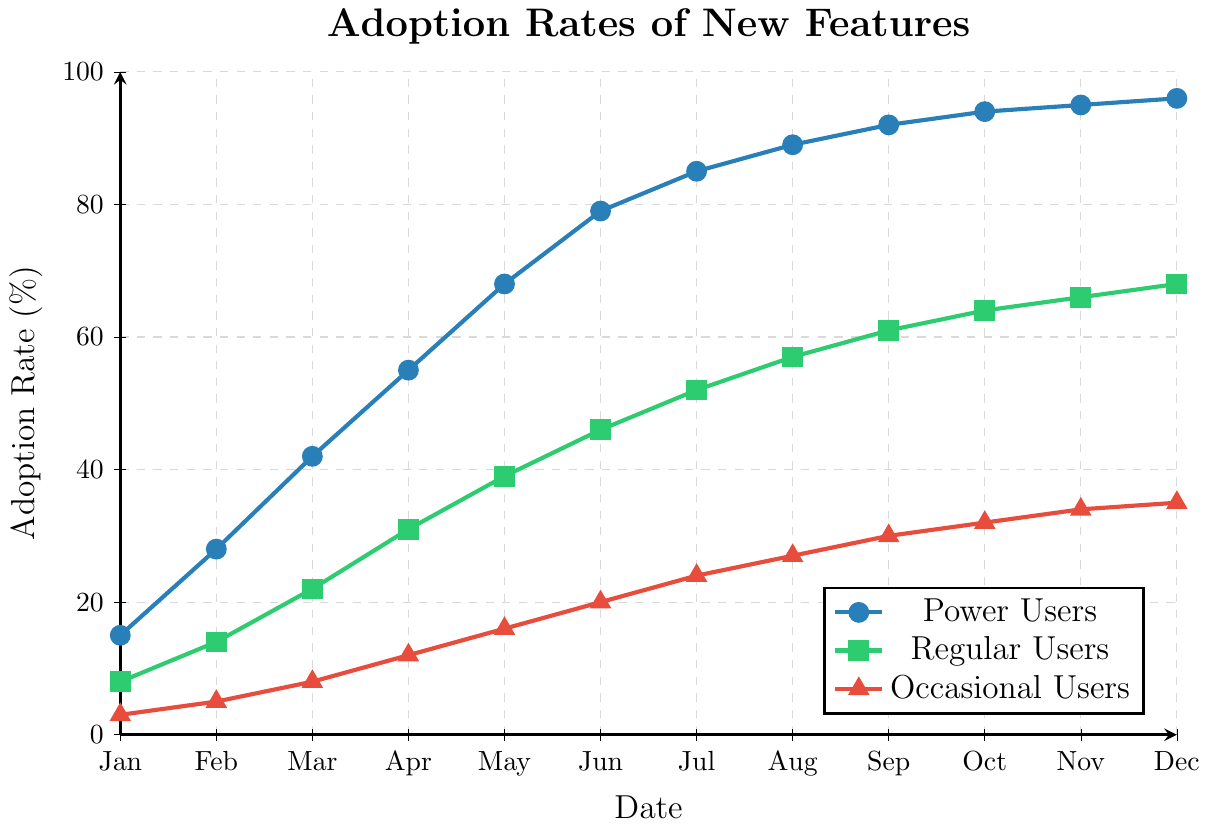What is the adoption rate for Power Users in July? To find the adoption rate for Power Users in July, locate the corresponding point on the line for Power Users (marked with circles). In July, the value is 85%.
Answer: 85% Which user segment showed the highest adoption rate in March? Compare the adoption rates for March (x-axis value 2) for all three user segments. Power Users had 42%, Regular Users had 22%, and Occasional Users had 8%. The highest adoption rate is for Power Users at 42%.
Answer: Power Users What is the average adoption rate for Regular Users from January to December? Sum the adoption rates for Regular Users for each month, then divide by the number of months: (8 + 14 + 22 + 31 + 39 + 46 + 52 + 57 + 61 + 64 + 66 + 68) / 12 = 528 / 12 = 44%.
Answer: 44% How much higher was the adoption rate for Occasional Users in December compared to January? Subtract the adoption rate for January (3%) from the adoption rate for December (35%): 35% - 3% = 32%.
Answer: 32% During which month did Power Users' adoption rate surpass 50%? Examine the line for Power Users and locate when it first exceeds 50%. In April, the adoption rate is 55%, which is the first month it surpasses 50%.
Answer: April Which user segment had the smallest increase in adoption rate from June to July? Calculate the increase for each segment: Power Users (85% - 79% = 6%), Regular Users (52% - 46% = 6%), Occasional Users (24% - 20% = 4%). Occasional Users had the smallest increase of 4%.
Answer: Occasional Users By how much did the adoption rate of Regular Users increase from January to December? Subtract the adoption rate in January (8%) from the adoption rate in December (68%): 68% - 8% = 60%.
Answer: 60% Compare the adoption rates for all user segments in October. Which segment had the lowest rate? Look at the adoption rates for October: Power Users (94%), Regular Users (64%), and Occasional Users (32%). Occasional Users had the lowest adoption rate.
Answer: Occasional Users What is the difference in adoption rates between Power Users and Regular Users in September? Subtract the adoption rate of Regular Users in September (61%) from the adoption rate of Power Users in September (92%): 92% - 61% = 31%.
Answer: 31% Between which two consecutive months did Power Users experience the largest increase in adoption rate? Calculate the monthly increases and find the maximum: 
Feb-Jan (28% - 15% = 13%), Mar-Feb (42% - 28% = 14%), Apr-Mar (55% - 42% = 13%), May-Apr (68% - 55% = 13%), Jun-May (79% - 68% = 11%), Jul-Jun (85% - 79% = 6%), Aug-Jul (89% - 85% = 4%), Sep-Aug (92% - 89% = 3%), Oct-Sep (94% - 92% = 2%), Nov-Oct (95% - 94% = 1%), Dec-Nov (96% - 95% = 1%). The largest increase is from Mar-Feb (14%).
Answer: Feb to Mar 